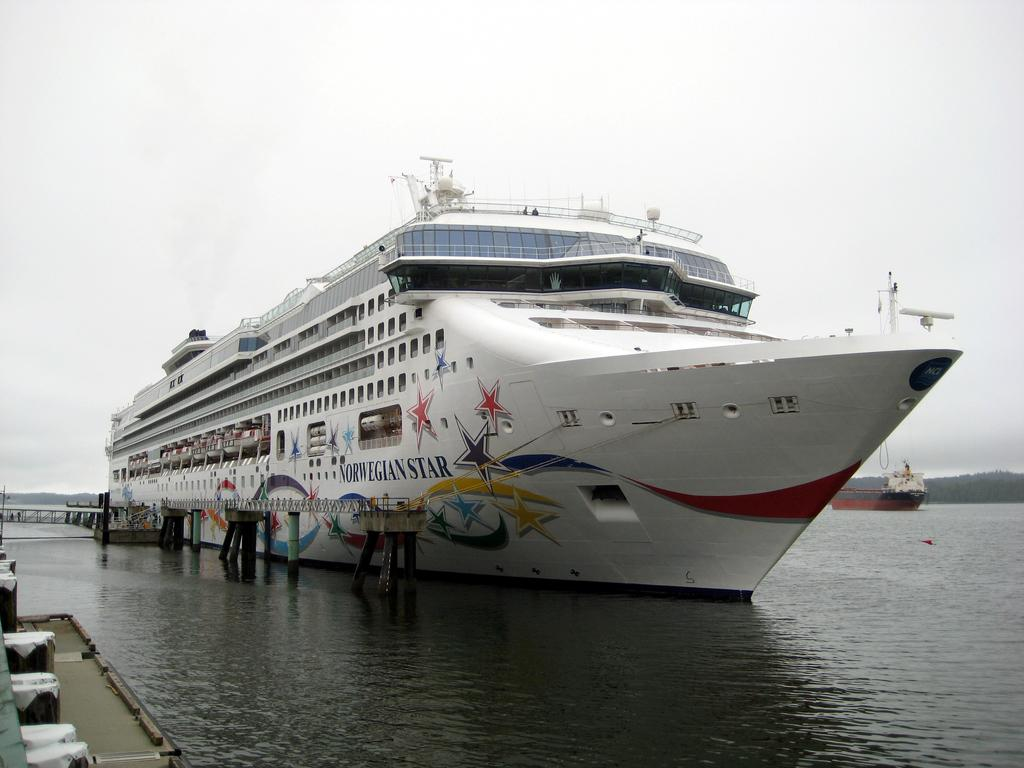What is the main subject of the image? There are two ships on the river in the image. Can you describe the setting of the image? The ships are on a river, with mountains in the background and the sky visible. How many ships can be seen in the image? There are two ships on the river in the image. What type of bucket is being used by the ship's crew in the image? There is no bucket visible in the image. What emotion can be seen on the faces of the ship's crew in the image? The image does not show the faces of the ship's crew, so it is impossible to determine their emotions. 